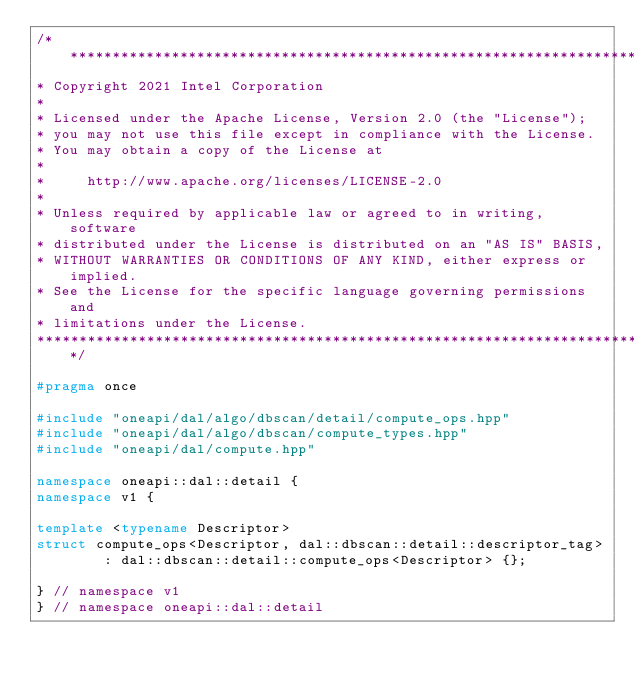<code> <loc_0><loc_0><loc_500><loc_500><_C++_>/*******************************************************************************
* Copyright 2021 Intel Corporation
*
* Licensed under the Apache License, Version 2.0 (the "License");
* you may not use this file except in compliance with the License.
* You may obtain a copy of the License at
*
*     http://www.apache.org/licenses/LICENSE-2.0
*
* Unless required by applicable law or agreed to in writing, software
* distributed under the License is distributed on an "AS IS" BASIS,
* WITHOUT WARRANTIES OR CONDITIONS OF ANY KIND, either express or implied.
* See the License for the specific language governing permissions and
* limitations under the License.
*******************************************************************************/

#pragma once

#include "oneapi/dal/algo/dbscan/detail/compute_ops.hpp"
#include "oneapi/dal/algo/dbscan/compute_types.hpp"
#include "oneapi/dal/compute.hpp"

namespace oneapi::dal::detail {
namespace v1 {

template <typename Descriptor>
struct compute_ops<Descriptor, dal::dbscan::detail::descriptor_tag>
        : dal::dbscan::detail::compute_ops<Descriptor> {};

} // namespace v1
} // namespace oneapi::dal::detail
</code> 